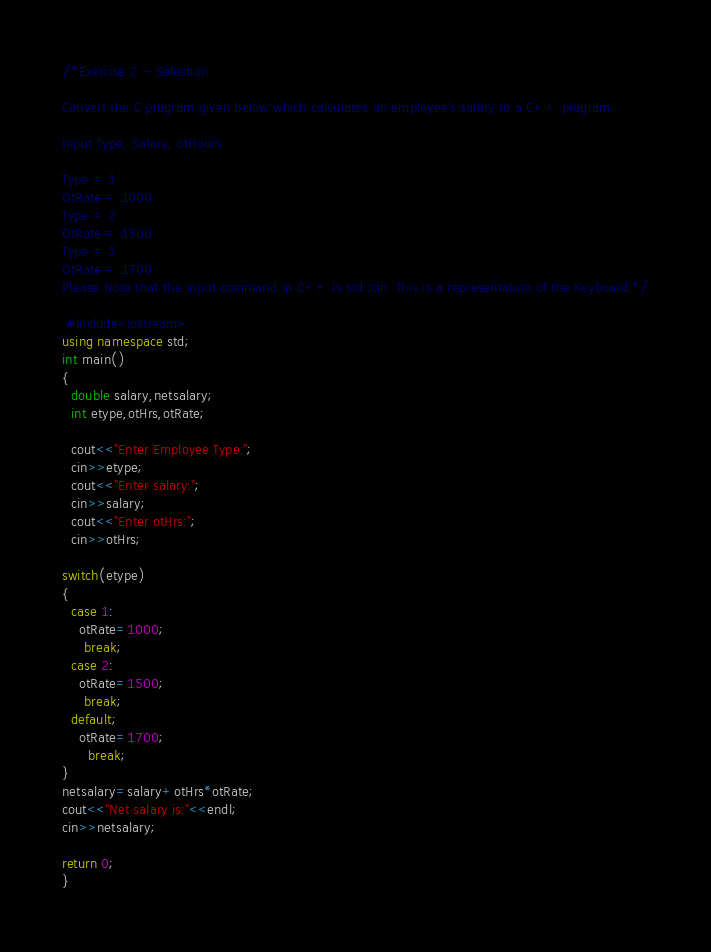Convert code to text. <code><loc_0><loc_0><loc_500><loc_500><_C++_>/*Exercise 2 - Selection

Convert the C program given below which calculates an employee's salary to a C++ program.

Input Type, Salary, otHours

Type = 1
OtRate = 1000
Type = 2
OtRate = 1500
Type = 3
OtRate = 1700
Please Note that the input command in C++ is std::cin. This is a representation of the Keyboard.*/

 #include<iostream>
using namespace std;
int main()
{
  double salary,netsalary;
  int etype,otHrs,otRate;

  cout<<"Enter Employee Type:";
  cin>>etype;
  cout<<"Enter salary:";
  cin>>salary;
  cout<<"Enter otHrs:";
  cin>>otHrs;

switch(etype)
{
  case 1:
    otRate=1000;
     break;
  case 2:
    otRate=1500;
     break;
  default;
    otRate=1700;
      break;
}
netsalary=salary+otHrs*otRate;
cout<<"Net salary is:"<<endl;
cin>>netsalary;

return 0;
}  
</code> 